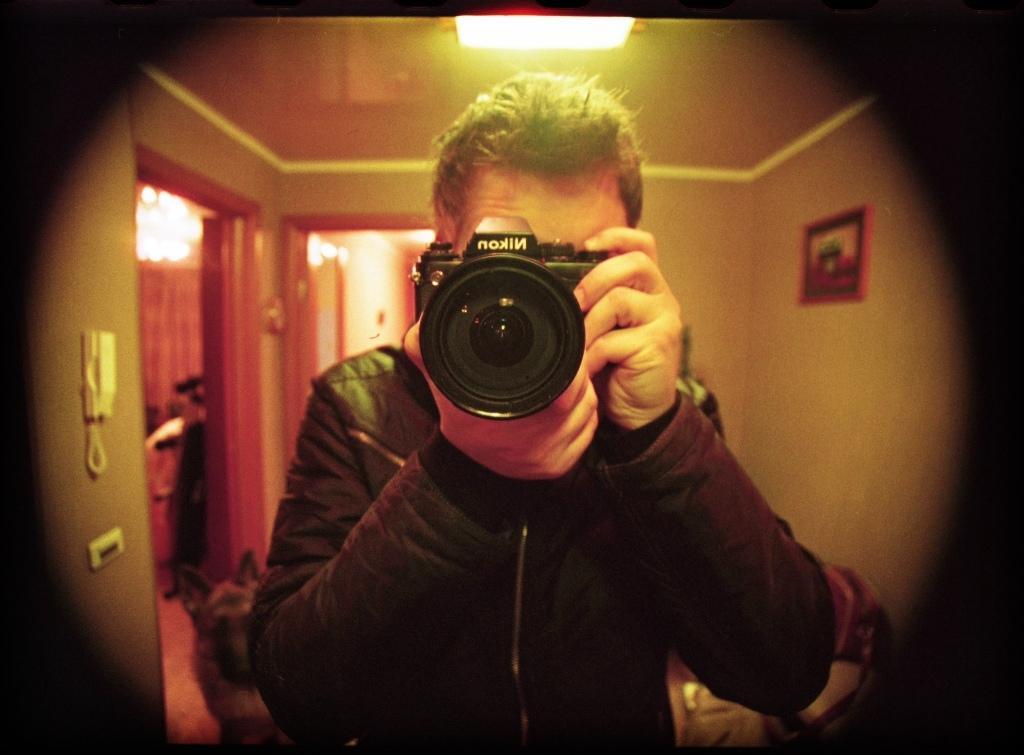Describe this image in one or two sentences. In this image there is a man standing and holding a camera in his hand. He is clicking a picture. On the camera "Nikon" is written. There is a light to the ceiling. In the background there is wall, door and a picture frame hanging on wall. 